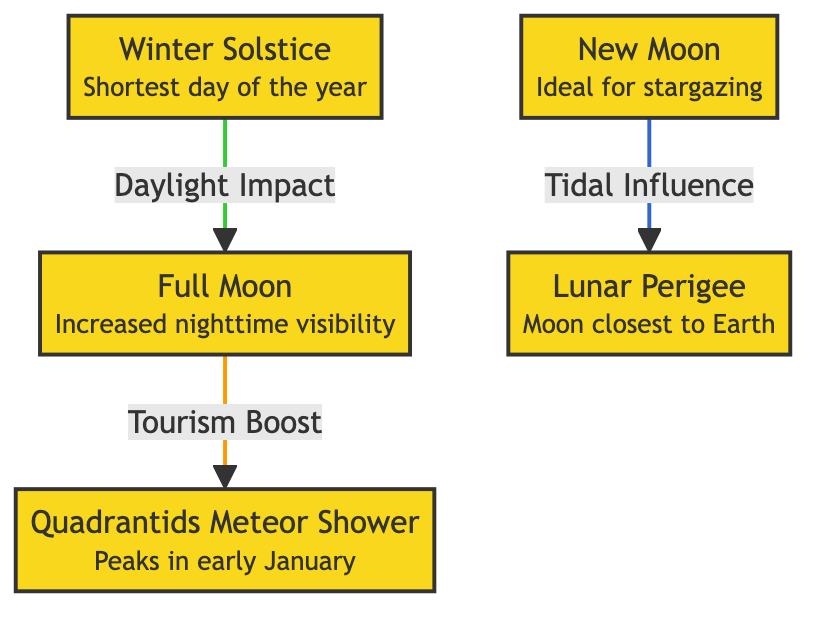What is the first event listed in the diagram? The first event shown in the diagram is "Full Moon" which is at the top.
Answer: Full Moon How many events are represented in the diagram? There are a total of five events represented in the diagram, counting each labeled node.
Answer: 5 Which event is linked to "Tourism Boost"? The event that is linked to "Tourism Boost" is "Full Moon". This is shown through the directional arrow.
Answer: Full Moon What is the impact of the Winter Solstice on the Full Moon? The impact is "Daylight Impact", as indicated by the arrow connecting Winter Solstice to Full Moon.
Answer: Daylight Impact Which event is associated with the closest moon position? The event associated with the closest moon position is "Lunar Perigee", as noted in its description.
Answer: Lunar Perigee How do the New Moon and Lunar Perigee relate in terms of impact? The New Moon affects the Lunar Perigee through "Tidal Influence", creating a direct connection in the diagram.
Answer: Tidal Influence Identify the event that peaks in early January. The event that peaks in early January is the "Quadrantids Meteor Shower", explicitly mentioned in its description.
Answer: Quadrantids Meteor Shower What is the connection between the Full Moon and the Quadrantids Meteor Shower? The connection is that the Full Moon leads to a "Tourism Boost", impacting the Quadrantids Meteor Shower.
Answer: Tourism Boost Which event has a description that refers to a specific day? The event that refers to a specific day is the "Winter Solstice", as it states "Shortest day of the year".
Answer: Winter Solstice 